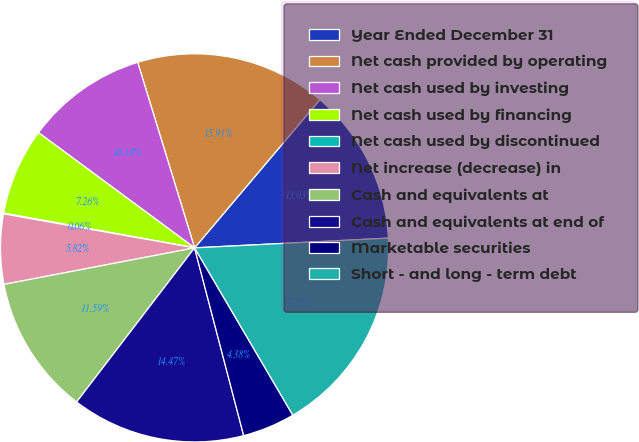<chart> <loc_0><loc_0><loc_500><loc_500><pie_chart><fcel>Year Ended December 31<fcel>Net cash provided by operating<fcel>Net cash used by investing<fcel>Net cash used by financing<fcel>Net cash used by discontinued<fcel>Net increase (decrease) in<fcel>Cash and equivalents at<fcel>Cash and equivalents at end of<fcel>Marketable securities<fcel>Short - and long - term debt<nl><fcel>13.03%<fcel>15.91%<fcel>10.14%<fcel>7.26%<fcel>0.06%<fcel>5.82%<fcel>11.59%<fcel>14.47%<fcel>4.38%<fcel>17.35%<nl></chart> 